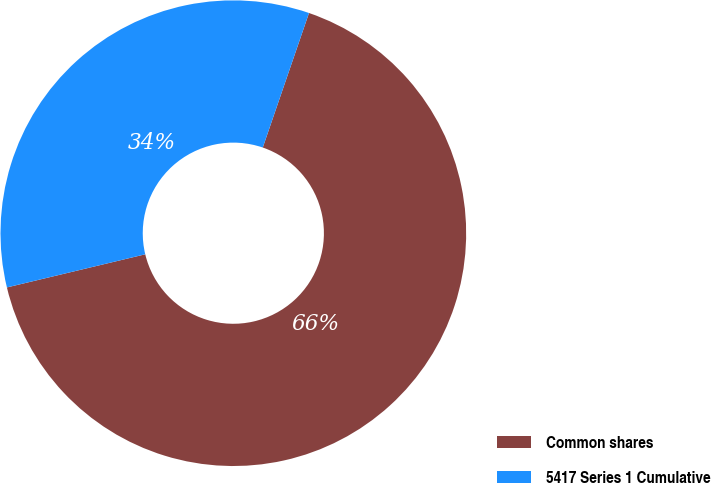Convert chart. <chart><loc_0><loc_0><loc_500><loc_500><pie_chart><fcel>Common shares<fcel>5417 Series 1 Cumulative<nl><fcel>65.99%<fcel>34.01%<nl></chart> 